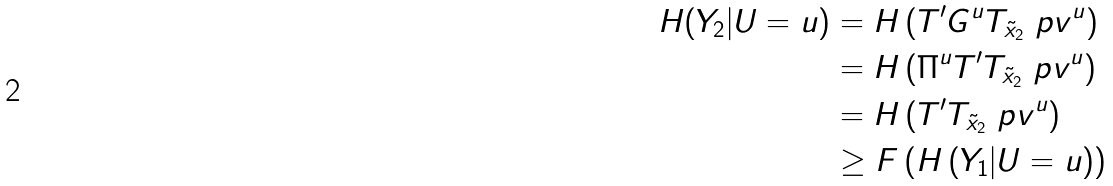Convert formula to latex. <formula><loc_0><loc_0><loc_500><loc_500>H ( Y _ { 2 } | U = u ) & = H \left ( T ^ { \prime } G ^ { u } T _ { \tilde { x } _ { 2 } } \ p v ^ { u } \right ) \\ & = H \left ( \Pi ^ { u } T ^ { \prime } T _ { \tilde { x } _ { 2 } } \ p v ^ { u } \right ) \\ & = H \left ( T ^ { \prime } T _ { \tilde { x } _ { 2 } } \ p v ^ { u } \right ) \\ & \geq F \left ( H \left ( Y _ { 1 } | U = u \right ) \right )</formula> 